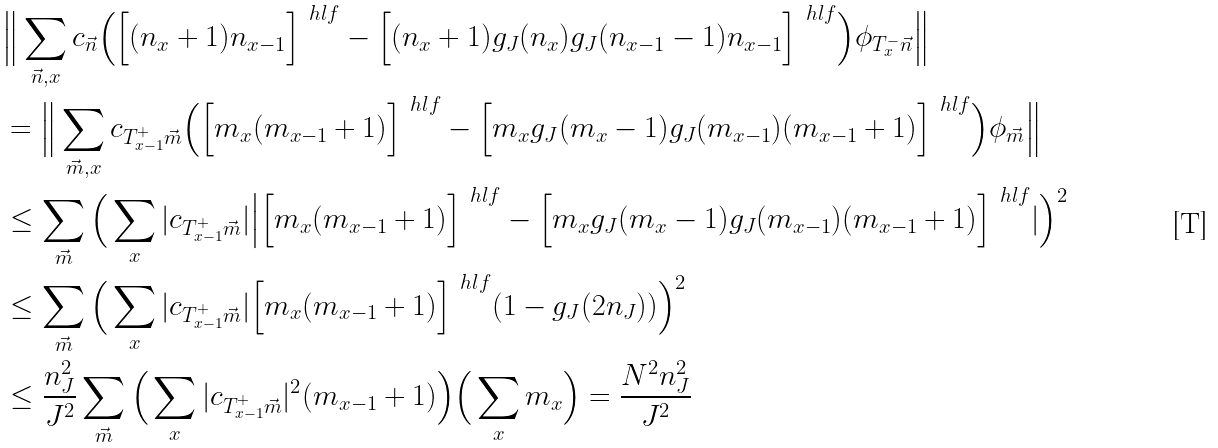<formula> <loc_0><loc_0><loc_500><loc_500>& \Big \| \sum _ { \vec { n } , x } c _ { \vec { n } } \Big ( \Big [ ( n _ { x } + 1 ) n _ { x - 1 } \Big ] ^ { \ h l f } - \Big [ ( n _ { x } + 1 ) g _ { J } ( n _ { x } ) g _ { J } ( n _ { x - 1 } - 1 ) n _ { x - 1 } \Big ] ^ { \ h l f } \Big ) \phi _ { T _ { x } ^ { - } \vec { n } } \Big \| \\ & = \Big \| \sum _ { \vec { m } , x } c _ { T _ { x - 1 } ^ { + } \vec { m } } \Big ( \Big [ m _ { x } ( m _ { x - 1 } + 1 ) \Big ] ^ { \ h l f } - \Big [ m _ { x } g _ { J } ( m _ { x } - 1 ) g _ { J } ( m _ { x - 1 } ) ( m _ { x - 1 } + 1 ) \Big ] ^ { \ h l f } \Big ) \phi _ { \vec { m } } \Big \| \\ & \leq \sum _ { \vec { m } } \Big ( \sum _ { x } | c _ { T _ { x - 1 } ^ { + } \vec { m } } | \Big | \Big [ m _ { x } ( m _ { x - 1 } + 1 ) \Big ] ^ { \ h l f } - \Big [ m _ { x } g _ { J } ( m _ { x } - 1 ) g _ { J } ( m _ { x - 1 } ) ( m _ { x - 1 } + 1 ) \Big ] ^ { \ h l f } | \Big ) ^ { 2 } \\ & \leq \sum _ { \vec { m } } \Big ( \sum _ { x } | c _ { T _ { x - 1 } ^ { + } \vec { m } } | \Big [ m _ { x } ( m _ { x - 1 } + 1 ) \Big ] ^ { \ h l f } ( 1 - g _ { J } ( 2 n _ { J } ) ) \Big ) ^ { 2 } \\ & \leq \frac { n _ { J } ^ { 2 } } { J ^ { 2 } } \sum _ { \vec { m } } \Big ( \sum _ { x } | c _ { T _ { x - 1 } ^ { + } \vec { m } } | ^ { 2 } ( m _ { x - 1 } + 1 ) \Big ) \Big ( \sum _ { x } m _ { x } \Big ) = \frac { N ^ { 2 } n _ { J } ^ { 2 } } { J ^ { 2 } }</formula> 